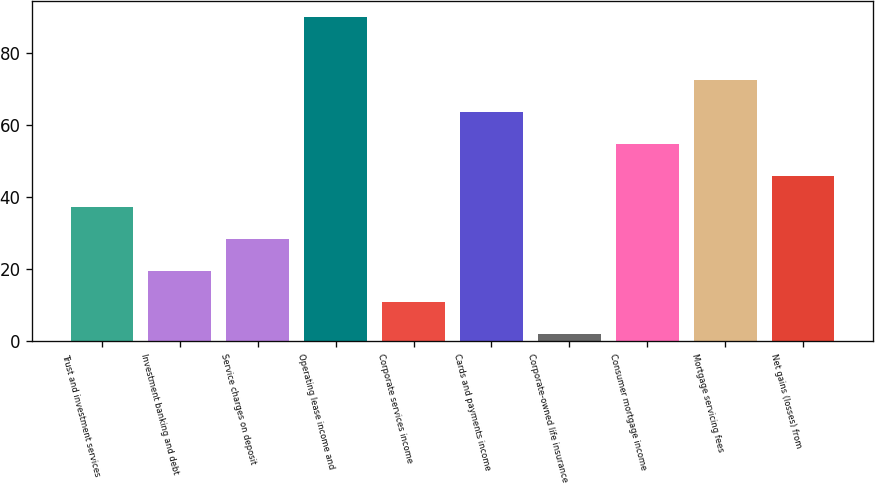<chart> <loc_0><loc_0><loc_500><loc_500><bar_chart><fcel>Trust and investment services<fcel>Investment banking and debt<fcel>Service charges on deposit<fcel>Operating lease income and<fcel>Corporate services income<fcel>Cards and payments income<fcel>Corporate-owned life insurance<fcel>Consumer mortgage income<fcel>Mortgage servicing fees<fcel>Net gains (losses) from<nl><fcel>37.2<fcel>19.6<fcel>28.4<fcel>90<fcel>10.8<fcel>63.6<fcel>2<fcel>54.8<fcel>72.4<fcel>46<nl></chart> 